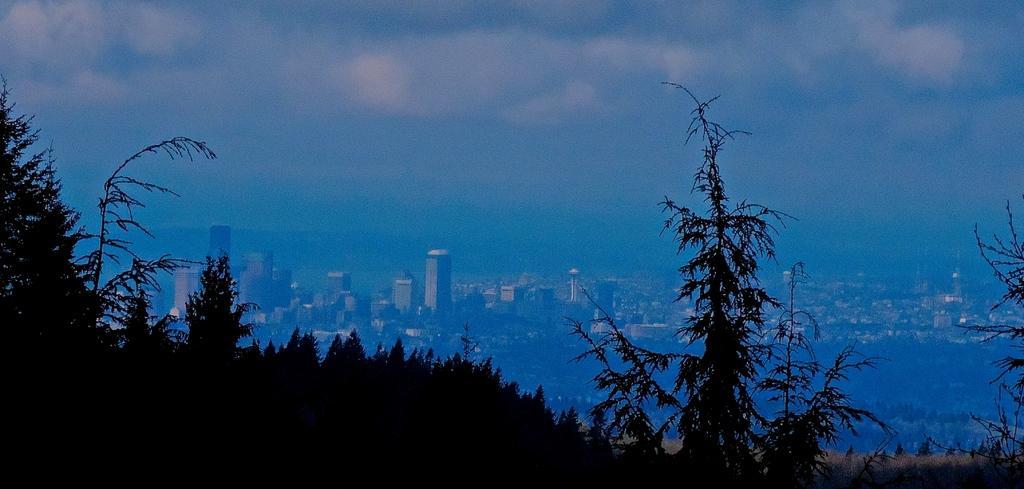Could you give a brief overview of what you see in this image? This is an aerial view. In the center of the image we can see the buildings. At the bottom of the image we can see the trees and ground. At the top of the image we can see the clouds are present in the sky. 